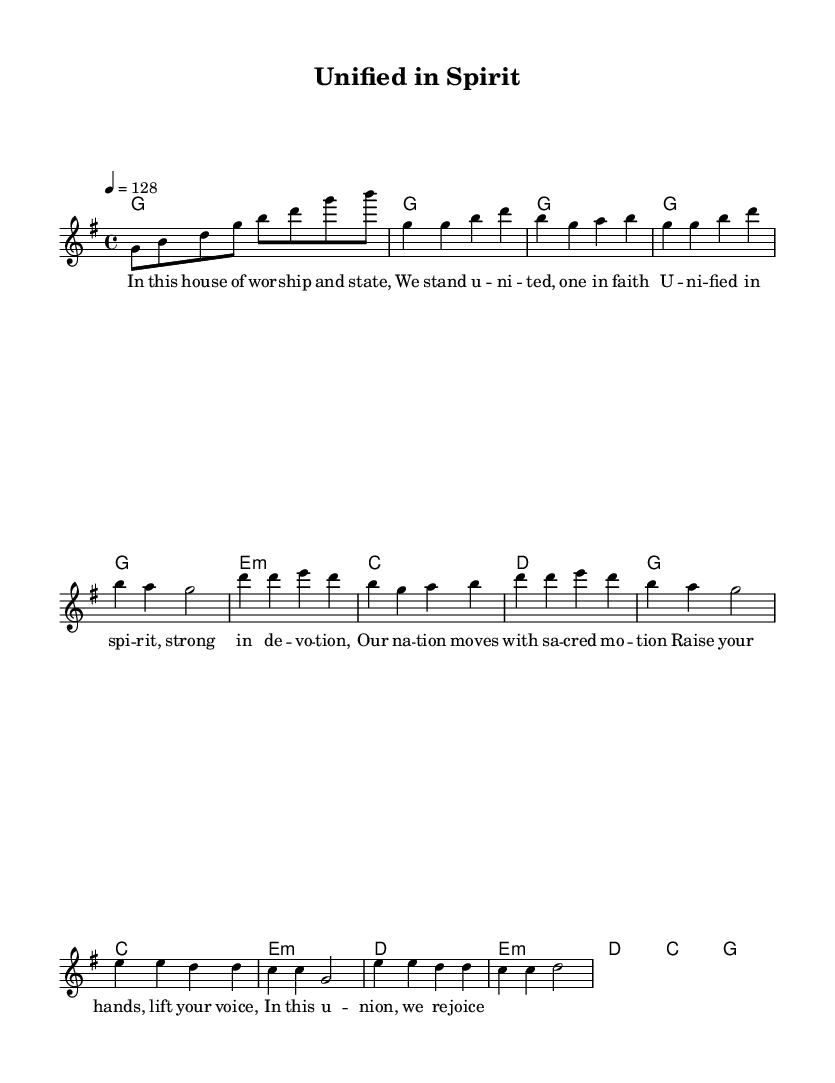What is the key signature of this music? The key signature is G major, as indicated by the one sharp (F#) shown at the beginning of the score.
Answer: G major What is the time signature of this piece? The time signature is 4/4, which means there are four beats in each measure and a quarter note gets one beat. This is indicated at the beginning of the score.
Answer: 4/4 What is the tempo marking for this music? The tempo marking is quarter note equals 128, which indicates that the piece should be played at a moderate tempo. This is also found at the top of the sheet music.
Answer: 128 How many measures are in the Chorus? The Chorus consists of 4 measures as indicated by the counting of the measures from the start to the end of the chorus section in the melody part.
Answer: 4 What is the lyrical theme expressed in the verse? The verse expresses themes of unity and faith within a worship context, as derived from the text presented in the verse lyric section.
Answer: Unity and faith Which section of the music contains the bridge? The bridge is located after the Chorus and is a separate section with distinct lyrics and melody pattern, clearly labeled in the score.
Answer: Bridge What kind of chords are primarily used in the harmony section? The harmony section features both major and minor chords, such as G major, E minor, C major, and D major, contributing to a gospel-infused sound typical in modern worship music.
Answer: Major and minor chords 